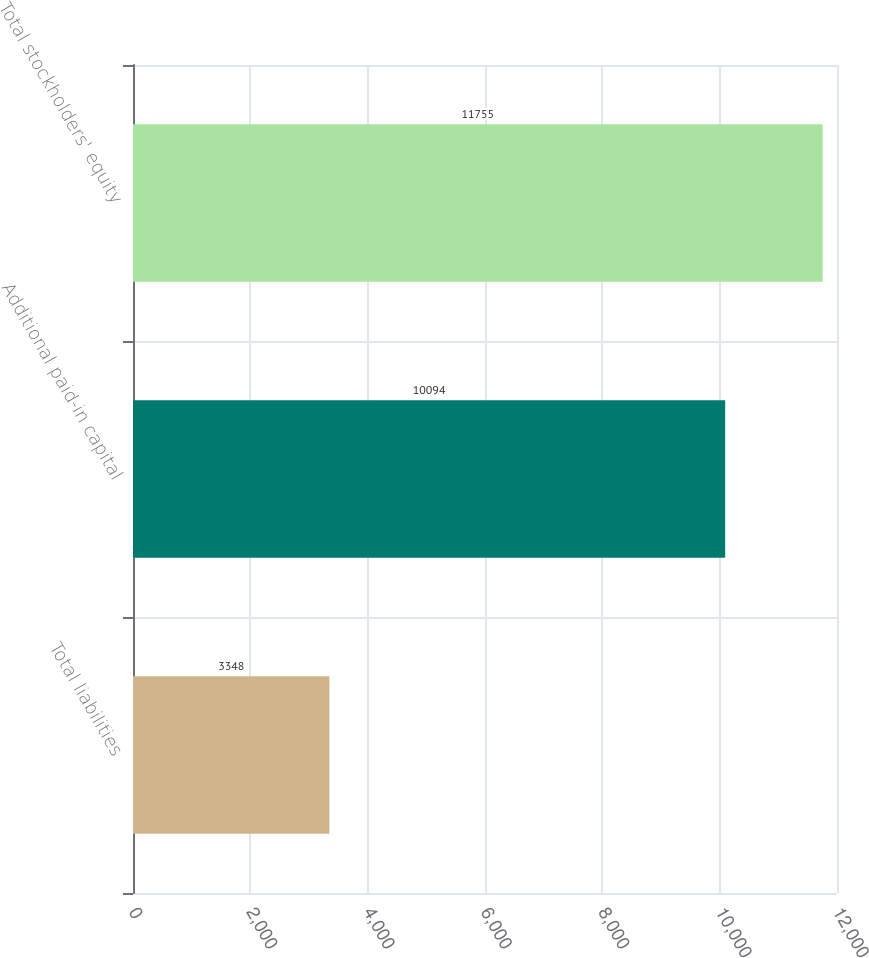Convert chart. <chart><loc_0><loc_0><loc_500><loc_500><bar_chart><fcel>Total liabilities<fcel>Additional paid-in capital<fcel>Total stockholders' equity<nl><fcel>3348<fcel>10094<fcel>11755<nl></chart> 